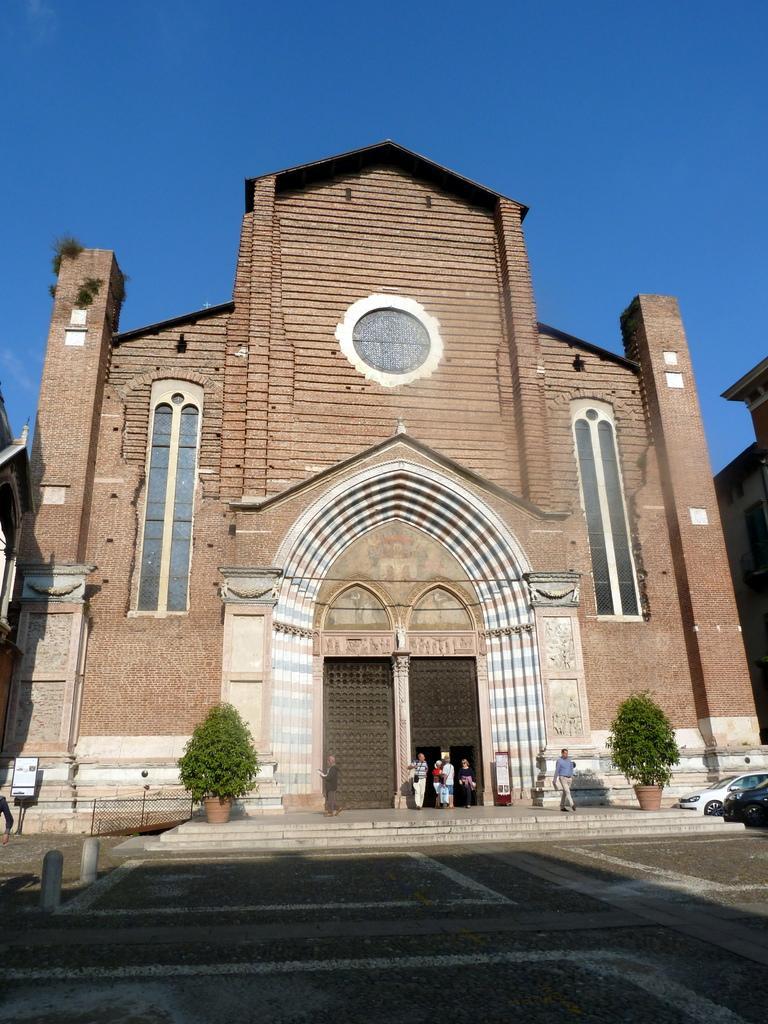In one or two sentences, can you explain what this image depicts? At the bottom of the image there is a floor. There is a building with walls, windows, arches and doors. Also there are steps. There are pots with plants on the floor. On the right side of the image there are vehicles. At the top of the image there is a sky. 